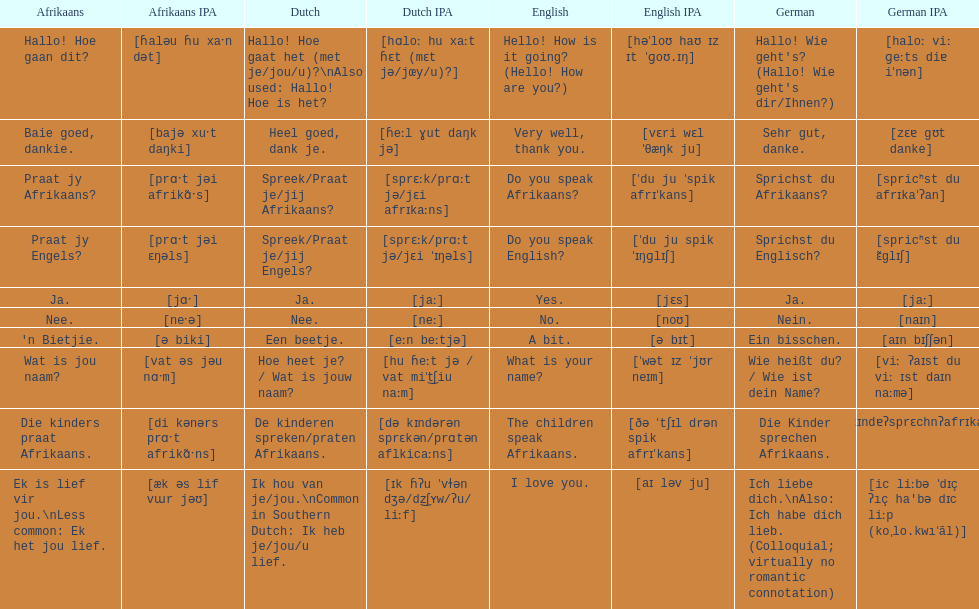How do you say 'do you speak afrikaans?' in afrikaans? Praat jy Afrikaans?. 